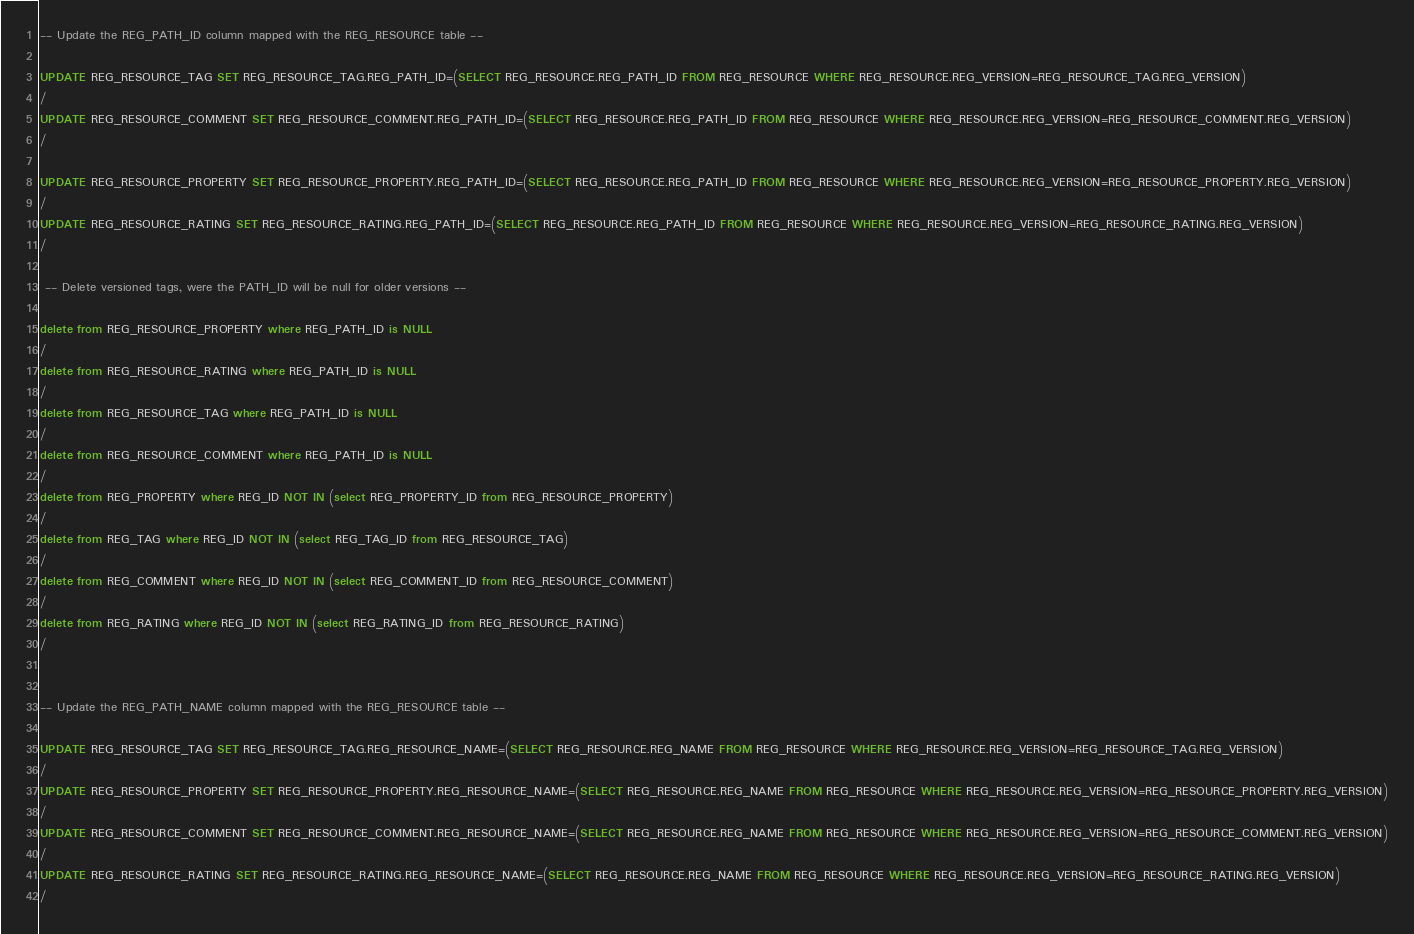<code> <loc_0><loc_0><loc_500><loc_500><_SQL_>-- Update the REG_PATH_ID column mapped with the REG_RESOURCE table --

UPDATE REG_RESOURCE_TAG SET REG_RESOURCE_TAG.REG_PATH_ID=(SELECT REG_RESOURCE.REG_PATH_ID FROM REG_RESOURCE WHERE REG_RESOURCE.REG_VERSION=REG_RESOURCE_TAG.REG_VERSION)
/
UPDATE REG_RESOURCE_COMMENT SET REG_RESOURCE_COMMENT.REG_PATH_ID=(SELECT REG_RESOURCE.REG_PATH_ID FROM REG_RESOURCE WHERE REG_RESOURCE.REG_VERSION=REG_RESOURCE_COMMENT.REG_VERSION)
/

UPDATE REG_RESOURCE_PROPERTY SET REG_RESOURCE_PROPERTY.REG_PATH_ID=(SELECT REG_RESOURCE.REG_PATH_ID FROM REG_RESOURCE WHERE REG_RESOURCE.REG_VERSION=REG_RESOURCE_PROPERTY.REG_VERSION)
/
UPDATE REG_RESOURCE_RATING SET REG_RESOURCE_RATING.REG_PATH_ID=(SELECT REG_RESOURCE.REG_PATH_ID FROM REG_RESOURCE WHERE REG_RESOURCE.REG_VERSION=REG_RESOURCE_RATING.REG_VERSION)
/

 -- Delete versioned tags, were the PATH_ID will be null for older versions --

delete from REG_RESOURCE_PROPERTY where REG_PATH_ID is NULL
/
delete from REG_RESOURCE_RATING where REG_PATH_ID is NULL
/
delete from REG_RESOURCE_TAG where REG_PATH_ID is NULL
/
delete from REG_RESOURCE_COMMENT where REG_PATH_ID is NULL
/
delete from REG_PROPERTY where REG_ID NOT IN (select REG_PROPERTY_ID from REG_RESOURCE_PROPERTY)
/
delete from REG_TAG where REG_ID NOT IN (select REG_TAG_ID from REG_RESOURCE_TAG)
/
delete from REG_COMMENT where REG_ID NOT IN (select REG_COMMENT_ID from REG_RESOURCE_COMMENT)
/
delete from REG_RATING where REG_ID NOT IN (select REG_RATING_ID from REG_RESOURCE_RATING)
/


-- Update the REG_PATH_NAME column mapped with the REG_RESOURCE table --

UPDATE REG_RESOURCE_TAG SET REG_RESOURCE_TAG.REG_RESOURCE_NAME=(SELECT REG_RESOURCE.REG_NAME FROM REG_RESOURCE WHERE REG_RESOURCE.REG_VERSION=REG_RESOURCE_TAG.REG_VERSION)
/
UPDATE REG_RESOURCE_PROPERTY SET REG_RESOURCE_PROPERTY.REG_RESOURCE_NAME=(SELECT REG_RESOURCE.REG_NAME FROM REG_RESOURCE WHERE REG_RESOURCE.REG_VERSION=REG_RESOURCE_PROPERTY.REG_VERSION)
/
UPDATE REG_RESOURCE_COMMENT SET REG_RESOURCE_COMMENT.REG_RESOURCE_NAME=(SELECT REG_RESOURCE.REG_NAME FROM REG_RESOURCE WHERE REG_RESOURCE.REG_VERSION=REG_RESOURCE_COMMENT.REG_VERSION)
/
UPDATE REG_RESOURCE_RATING SET REG_RESOURCE_RATING.REG_RESOURCE_NAME=(SELECT REG_RESOURCE.REG_NAME FROM REG_RESOURCE WHERE REG_RESOURCE.REG_VERSION=REG_RESOURCE_RATING.REG_VERSION)
/
</code> 